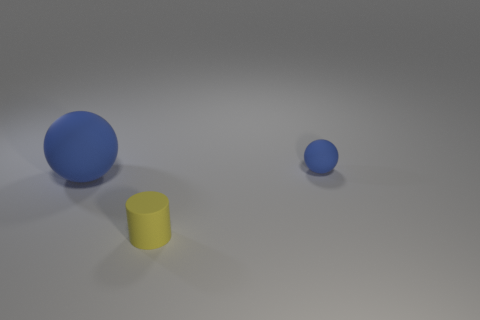Are there more small blue things on the right side of the small blue sphere than things that are right of the small yellow cylinder?
Offer a terse response. No. There is another blue sphere that is made of the same material as the large blue sphere; what size is it?
Keep it short and to the point. Small. What color is the matte sphere that is the same size as the cylinder?
Offer a terse response. Blue. What number of other matte things have the same size as the yellow thing?
Make the answer very short. 1. Do the small object to the right of the tiny yellow cylinder and the thing on the left side of the yellow cylinder have the same shape?
Keep it short and to the point. Yes. There is a thing that is the same color as the large rubber ball; what shape is it?
Give a very brief answer. Sphere. The matte cylinder that is to the left of the blue matte thing behind the large blue ball is what color?
Make the answer very short. Yellow. What color is the big rubber thing that is the same shape as the small blue object?
Your answer should be compact. Blue. Is there any other thing that has the same material as the large ball?
Offer a terse response. Yes. There is another thing that is the same shape as the big blue matte object; what is its size?
Offer a terse response. Small. 